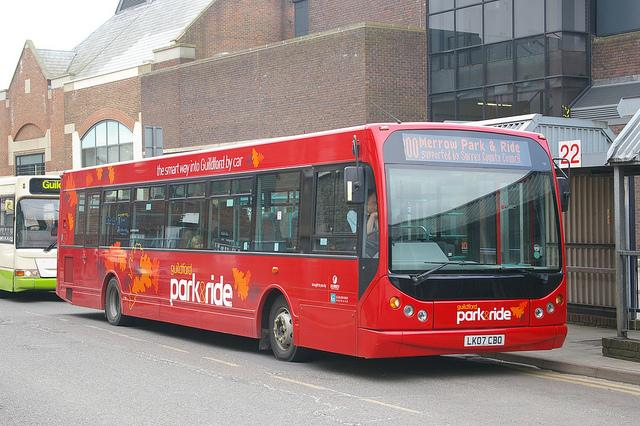What type of transportation is shown?

Choices:
A) air
B) rail
C) road
D) water road 